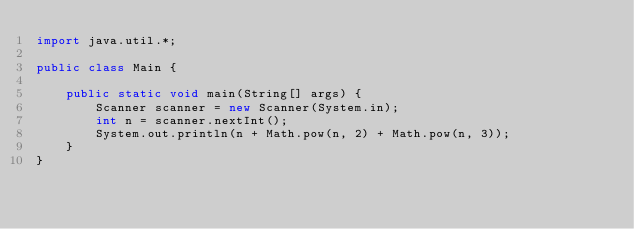<code> <loc_0><loc_0><loc_500><loc_500><_Java_>import java.util.*;

public class Main {

    public static void main(String[] args) {
        Scanner scanner = new Scanner(System.in);
        int n = scanner.nextInt();
        System.out.println(n + Math.pow(n, 2) + Math.pow(n, 3));
    }
}</code> 